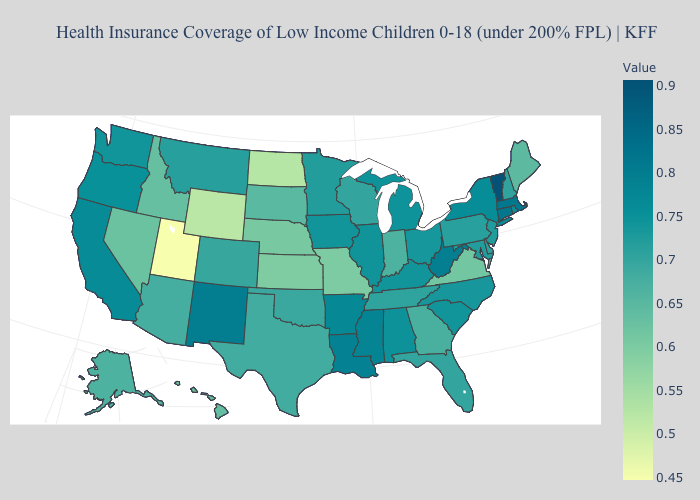Is the legend a continuous bar?
Answer briefly. Yes. Among the states that border West Virginia , does Kentucky have the highest value?
Short answer required. Yes. Does Arkansas have a higher value than Vermont?
Answer briefly. No. Among the states that border South Carolina , does North Carolina have the highest value?
Give a very brief answer. Yes. Which states have the lowest value in the West?
Write a very short answer. Utah. Does Georgia have the lowest value in the South?
Concise answer only. No. Does Kentucky have a higher value than Vermont?
Write a very short answer. No. Which states hav the highest value in the West?
Answer briefly. New Mexico. 